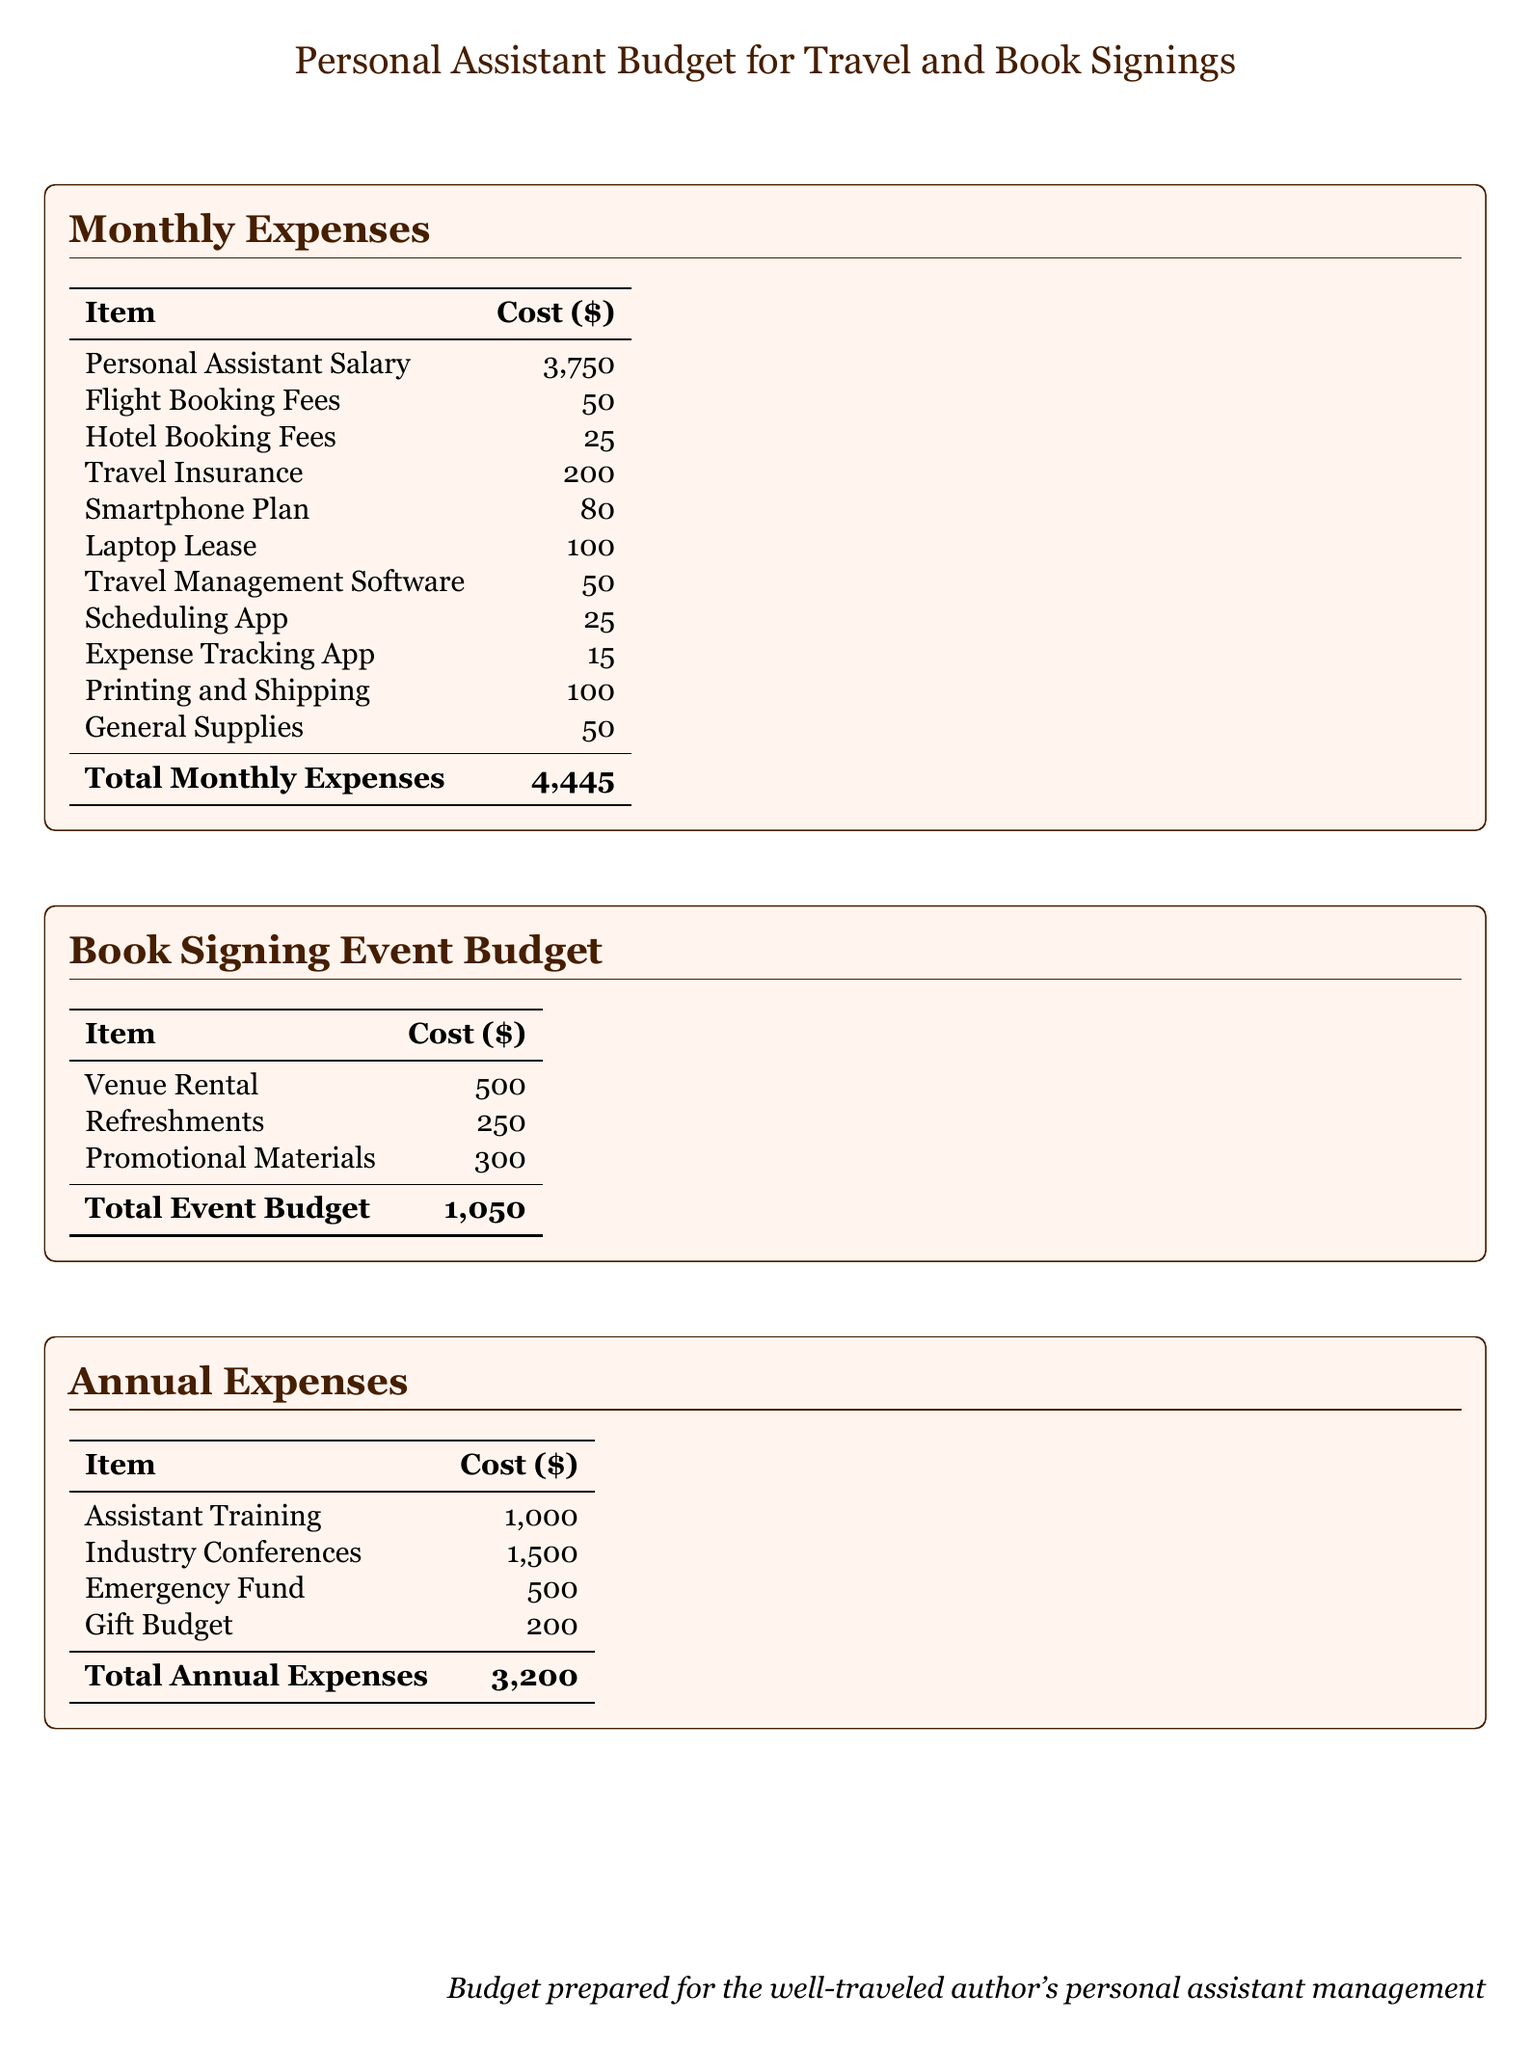what is the monthly salary of the personal assistant? The monthly salary is listed under "Personal Assistant Salary" in the Monthly Expenses section.
Answer: 3,750 what is the total monthly expense? The total monthly expense is provided at the bottom of the Monthly Expenses table.
Answer: 4,445 how much is allocated for venue rental in the book signing event budget? Venue rental costs are specified under the Book Signing Event Budget table.
Answer: 500 what is the cost of travel insurance? The cost is detailed in the Monthly Expenses section.
Answer: 200 what is the total annual expense? The total annual expense is calculated from the Annual Expenses table.
Answer: 3,200 how much is spent on promotional materials for the book signing event? Promotional materials costs are delineated in the Book Signing Event Budget.
Answer: 300 how much is budgeted for assistant training? Assistant training costs are specified in the Annual Expenses section.
Answer: 1,000 which item has the lowest cost in the Monthly Expenses? The item with the lowest cost is noted at the end of the Monthly Expenses table.
Answer: 15 what is the total cost for refreshments in the book signing event? Refreshments costs are provided in the Book Signing Event Budget table.
Answer: 250 how much is the emergency fund allocated for in annual expenses? The emergency fund allocation is listed under the Annual Expenses section.
Answer: 500 